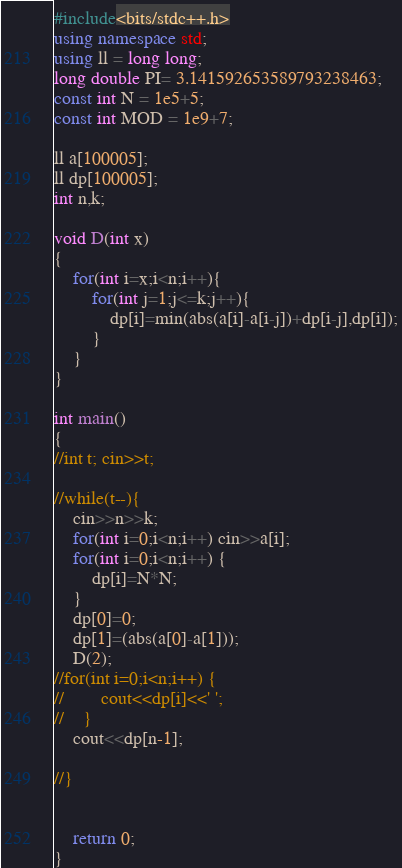<code> <loc_0><loc_0><loc_500><loc_500><_C++_>#include<bits/stdc++.h>
using namespace std;
using ll = long long;
long double PI= 3.141592653589793238463;
const int N = 1e5+5;
const int MOD = 1e9+7;

ll a[100005];
ll dp[100005];
int n,k;

void D(int x)
{
    for(int i=x;i<n;i++){
        for(int j=1;j<=k;j++){
            dp[i]=min(abs(a[i]-a[i-j])+dp[i-j],dp[i]);
        }
    }
}

int main()
{
//int t; cin>>t;

//while(t--){
    cin>>n>>k;
    for(int i=0;i<n;i++) cin>>a[i];
    for(int i=0;i<n;i++) {
        dp[i]=N*N;
    }
    dp[0]=0;
    dp[1]=(abs(a[0]-a[1]));
    D(2);
//for(int i=0;i<n;i++) {
//        cout<<dp[i]<<' ';
//    }
    cout<<dp[n-1];

//}


    return 0;
}

</code> 